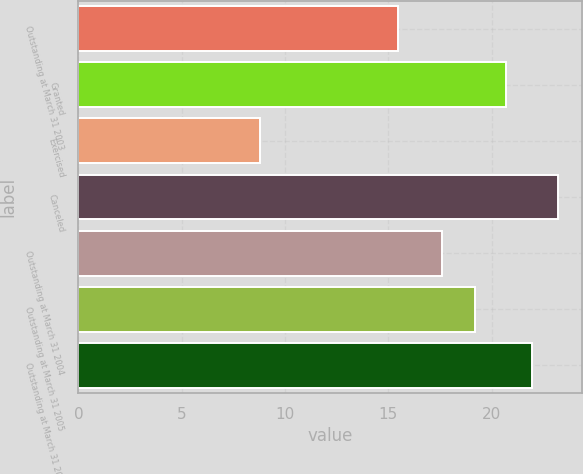Convert chart to OTSL. <chart><loc_0><loc_0><loc_500><loc_500><bar_chart><fcel>Outstanding at March 31 2003<fcel>Granted<fcel>Exercised<fcel>Canceled<fcel>Outstanding at March 31 2004<fcel>Outstanding at March 31 2005<fcel>Outstanding at March 31 2006<nl><fcel>15.45<fcel>20.68<fcel>8.79<fcel>23.22<fcel>17.6<fcel>19.19<fcel>21.95<nl></chart> 